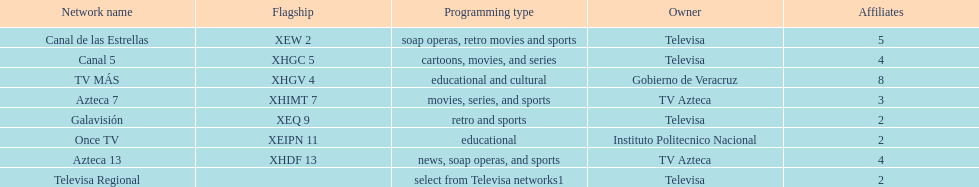Which is the only station with 8 affiliates? TV MÁS. 